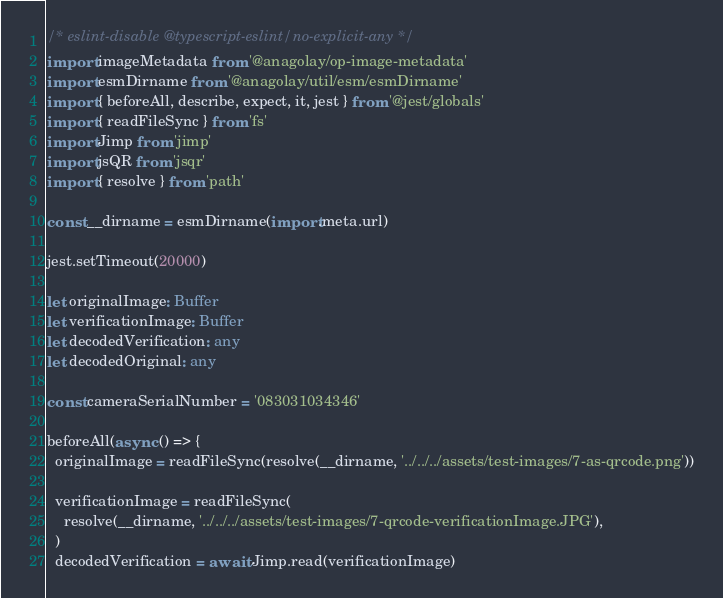<code> <loc_0><loc_0><loc_500><loc_500><_TypeScript_>/* eslint-disable @typescript-eslint/no-explicit-any */
import imageMetadata from '@anagolay/op-image-metadata'
import esmDirname from '@anagolay/util/esm/esmDirname'
import { beforeAll, describe, expect, it, jest } from '@jest/globals'
import { readFileSync } from 'fs'
import Jimp from 'jimp'
import jsQR from 'jsqr'
import { resolve } from 'path'

const __dirname = esmDirname(import.meta.url)

jest.setTimeout(20000)

let originalImage: Buffer
let verificationImage: Buffer
let decodedVerification: any
let decodedOriginal: any

const cameraSerialNumber = '083031034346'

beforeAll(async () => {
  originalImage = readFileSync(resolve(__dirname, '../../../assets/test-images/7-as-qrcode.png'))

  verificationImage = readFileSync(
    resolve(__dirname, '../../../assets/test-images/7-qrcode-verificationImage.JPG'),
  )
  decodedVerification = await Jimp.read(verificationImage)</code> 